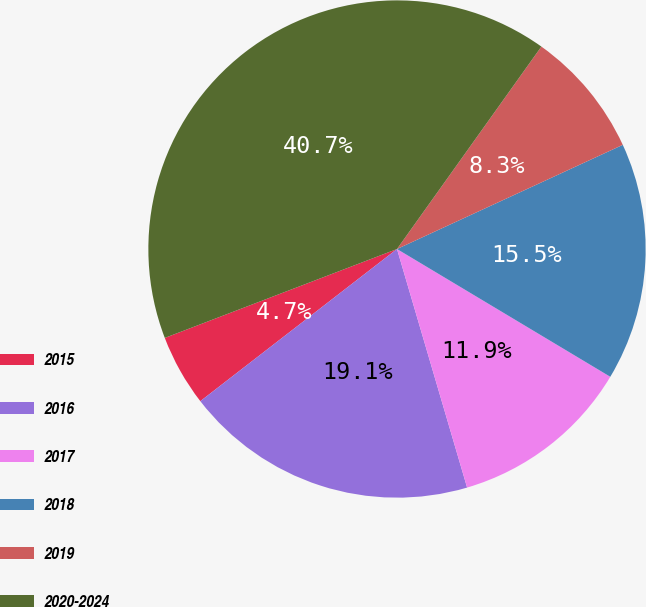Convert chart to OTSL. <chart><loc_0><loc_0><loc_500><loc_500><pie_chart><fcel>2015<fcel>2016<fcel>2017<fcel>2018<fcel>2019<fcel>2020-2024<nl><fcel>4.66%<fcel>19.07%<fcel>11.86%<fcel>15.47%<fcel>8.26%<fcel>40.68%<nl></chart> 